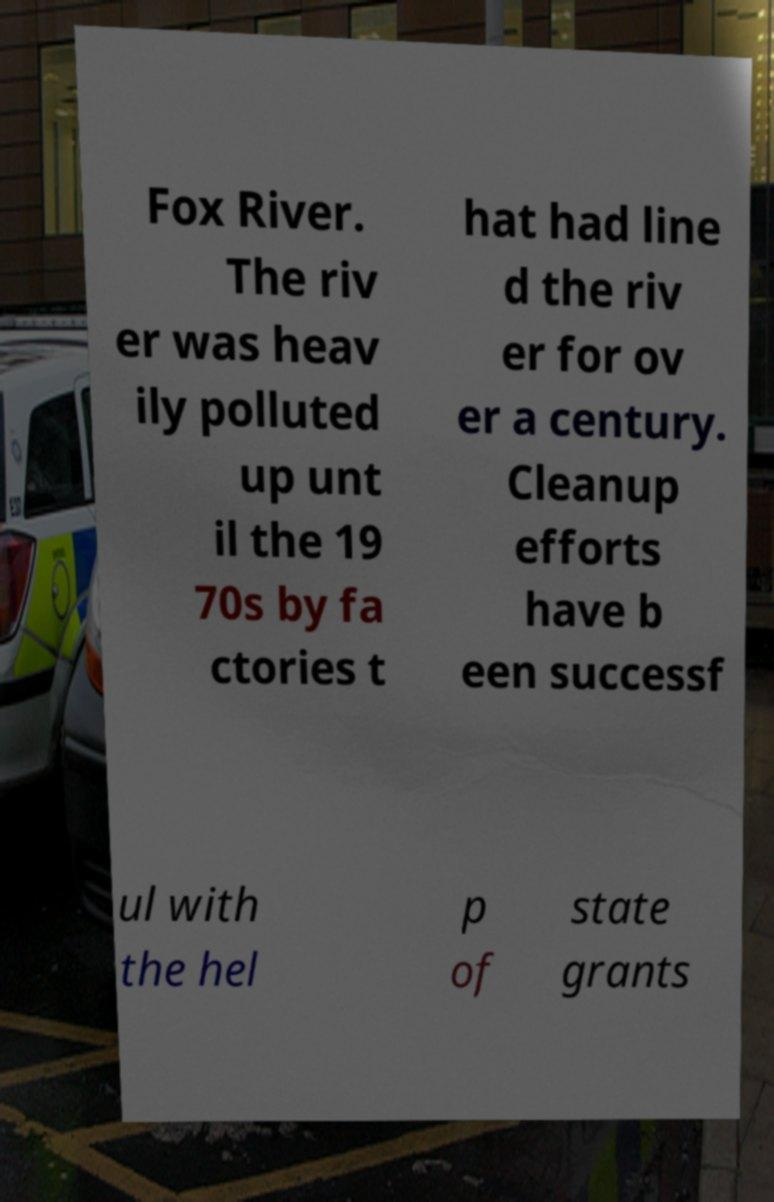Can you read and provide the text displayed in the image?This photo seems to have some interesting text. Can you extract and type it out for me? Fox River. The riv er was heav ily polluted up unt il the 19 70s by fa ctories t hat had line d the riv er for ov er a century. Cleanup efforts have b een successf ul with the hel p of state grants 